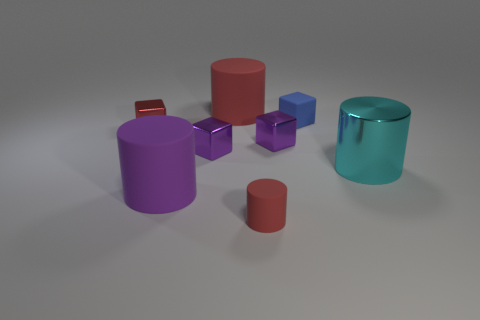Subtract 1 cubes. How many cubes are left? 3 Subtract all gray cylinders. Subtract all yellow blocks. How many cylinders are left? 4 Add 2 tiny matte objects. How many objects exist? 10 Add 6 large cyan cylinders. How many large cyan cylinders exist? 7 Subtract 0 blue balls. How many objects are left? 8 Subtract all tiny purple metallic things. Subtract all red cubes. How many objects are left? 5 Add 6 red metal objects. How many red metal objects are left? 7 